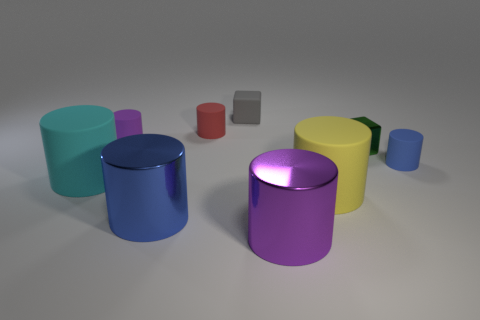Subtract all large blue shiny cylinders. How many cylinders are left? 6 Subtract all green blocks. How many blocks are left? 1 Subtract all blocks. How many objects are left? 7 Add 2 gray blocks. How many gray blocks exist? 3 Subtract 0 green cylinders. How many objects are left? 9 Subtract 1 cubes. How many cubes are left? 1 Subtract all cyan cylinders. Subtract all green blocks. How many cylinders are left? 6 Subtract all cyan balls. How many green cubes are left? 1 Subtract all rubber spheres. Subtract all blue metal cylinders. How many objects are left? 8 Add 3 big blue things. How many big blue things are left? 4 